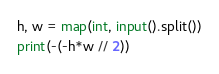Convert code to text. <code><loc_0><loc_0><loc_500><loc_500><_Python_>h, w = map(int, input().split())
print(-(-h*w // 2))</code> 